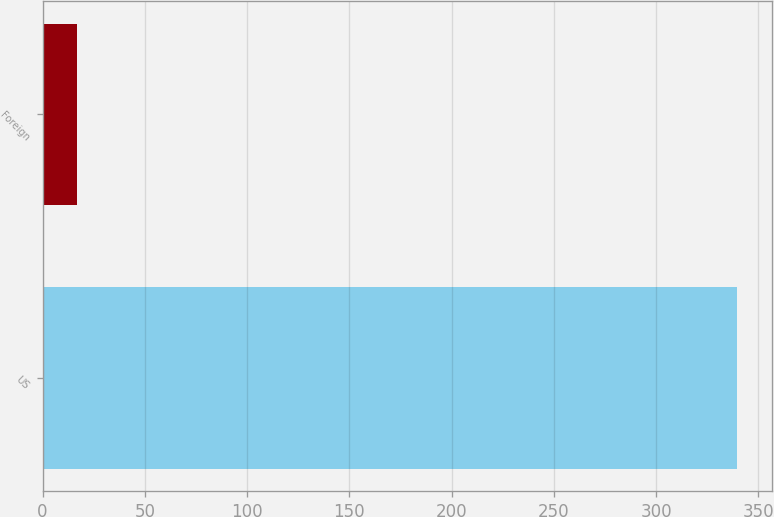<chart> <loc_0><loc_0><loc_500><loc_500><bar_chart><fcel>US<fcel>Foreign<nl><fcel>339.6<fcel>16.7<nl></chart> 